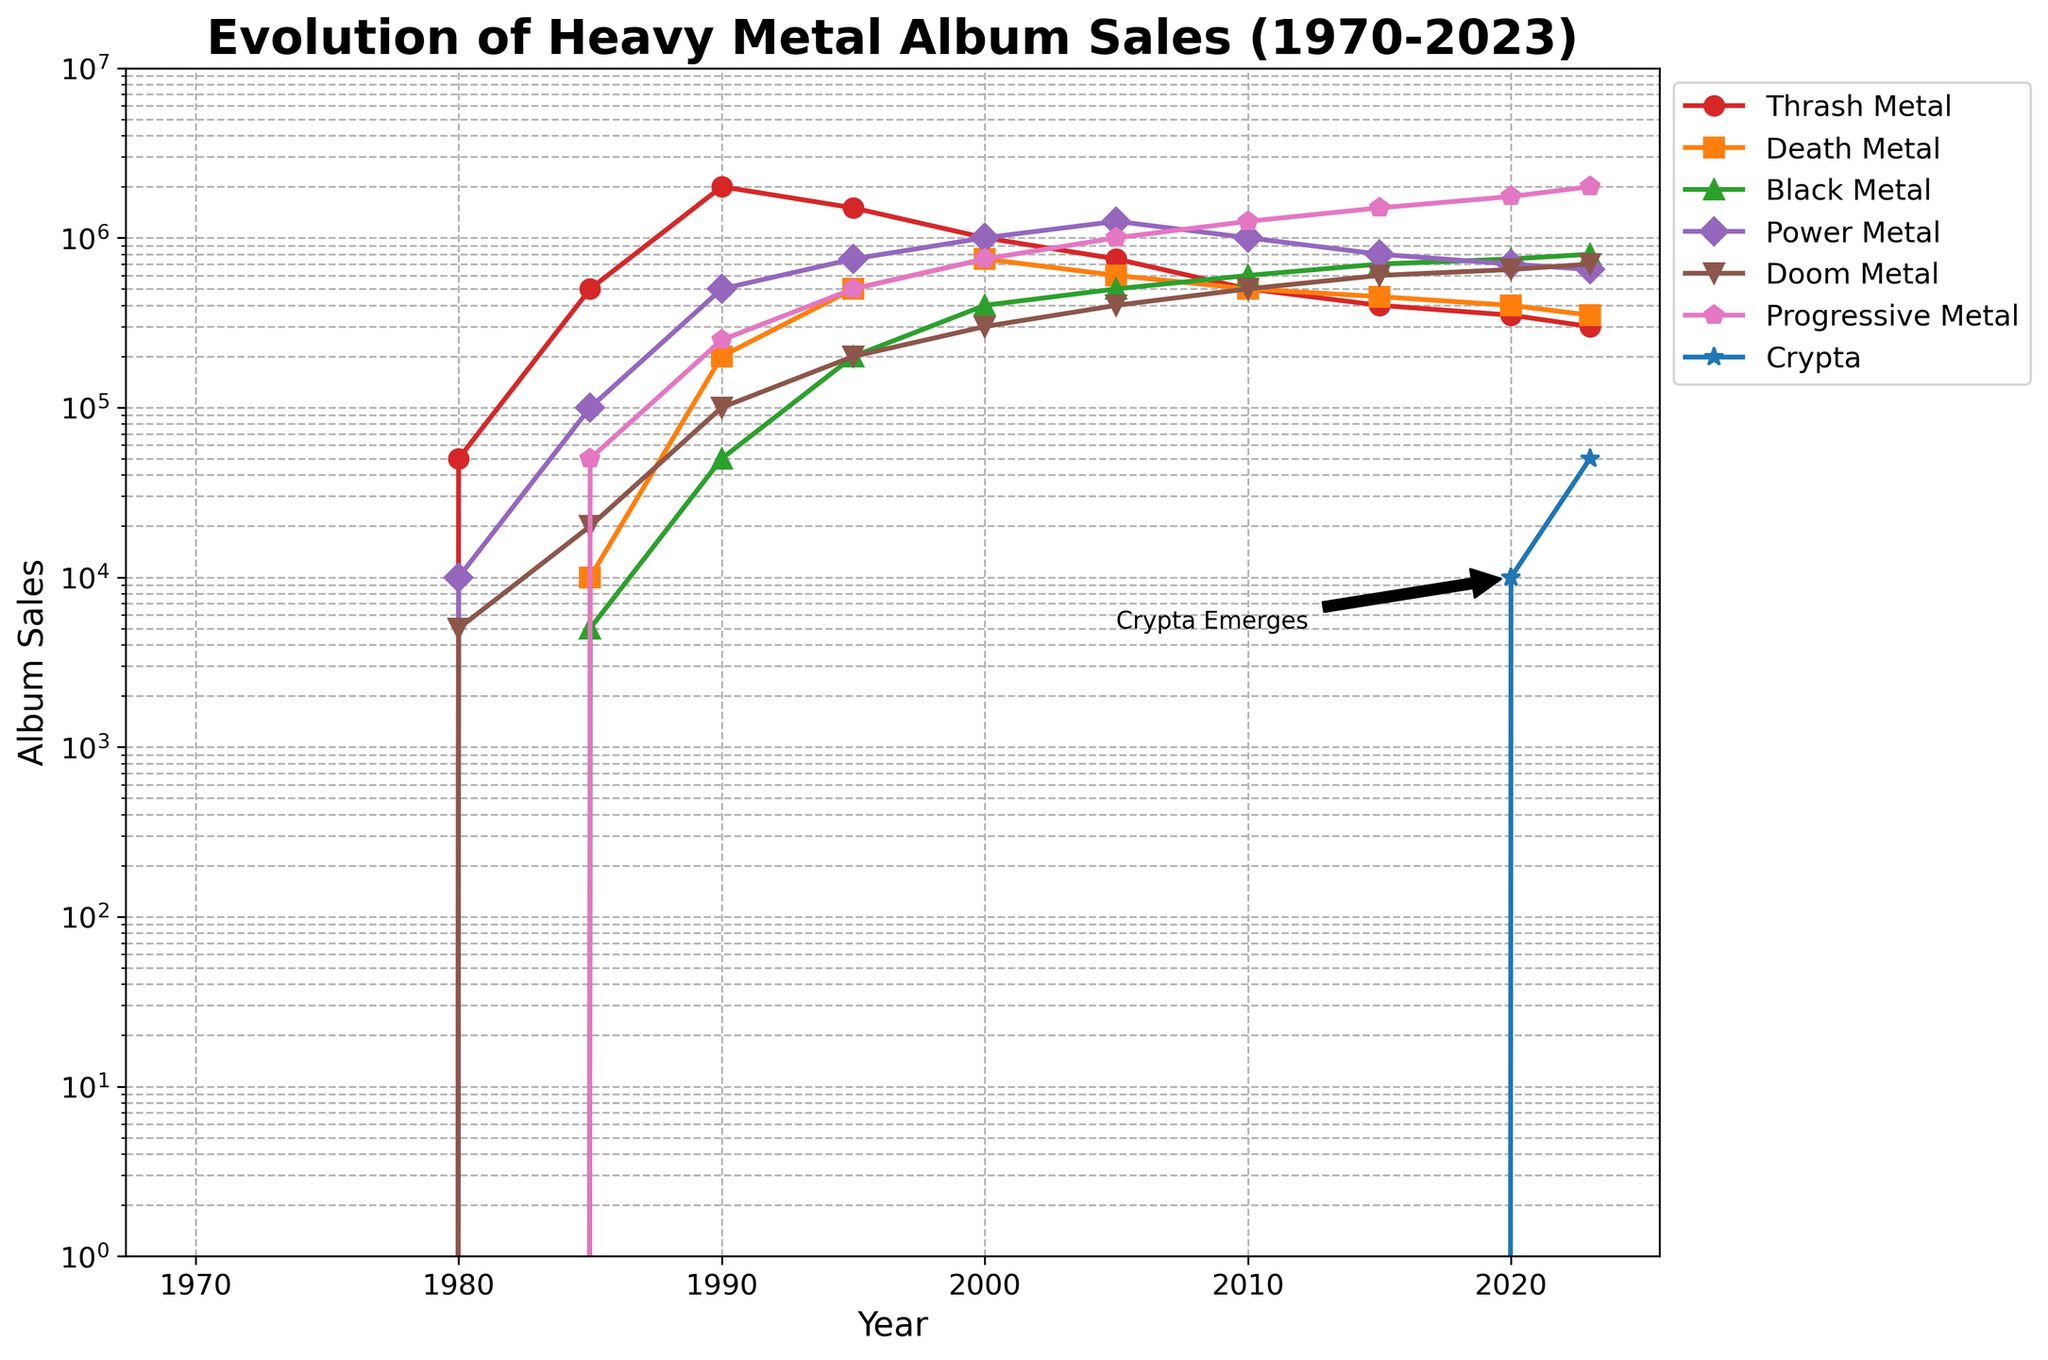What year did Progressive Metal first reach 1,000,000 in album sales? Progressive Metal reached 1,000,000 in album sales in 2005. You can see this because in 2005, the Progressive Metal line is at that point on the y-axis.
Answer: 2005 Which subgenre had the highest album sales in 1990? By looking at the lines on the plot for 1990, Thrash Metal had the highest peak.
Answer: Thrash Metal How did Crypta's album sales change from 2020 to 2023? From the plot, Crypta's sales increased from 10,000 in 2020 to 50,000 in 2023. Subtract the 2020 value from the 2023 value: 50,000 - 10,000 = 40,000.
Answer: Increased by 40,000 Compare the album sales of Doom Metal in 1985 and 2023. Which year had higher sales and by how much? For 1985, Doom Metal sales are at 20,000. For 2023, Doom Metal sales are at 700,000. 700,000 - 20,000 = 680,000. 2023 had higher sales by 680,000.
Answer: 2023 by 680,000 Which year did Death Metal first surpass 500,000 in album sales? In 1995, the Death Metal line crosses the 500,000 mark for the first time.
Answer: 1995 What is the overall trend of Black Metal album sales from 1980 to 2023? Observing the line for Black Metal, the sales generally increase over time from 0 in 1980 to 800,000 in 2023.
Answer: Increasing How much did Power Metal album sales change between 2000 and 2005? In 2000, Power Metal sales were 1,000,000, and in 2005 they were 1,250,000. The change is 1,250,000 - 1,000,000 = 250,000.
Answer: Increased by 250,000 Which subgenre showed the steepest decline in album sales from 1990 to 2000? Looking at the trend, Thrash Metal decreased the most sharply, from 2,000,000 in 1990 to 1,000,000 in 2000.
Answer: Thrash Metal How do the album sales of Crypta in 2023 compare to those of Death Metal in the same year? In 2023, Crypta had 50,000 sales, while Death Metal had 350,000. 350,000 - 50,000 = 300,000 more sales for Death Metal.
Answer: Death Metal had 300,000 more What is the visual annotation in the plot, and what does it signify? The visual annotation "Crypta Emerges" with an arrow pointing to 2020 indicates the year Crypta started gaining album sales.
Answer: Crypta started gaining sales in 2020 